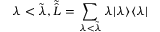Convert formula to latex. <formula><loc_0><loc_0><loc_500><loc_500>\lambda < \tilde { \lambda } , \tilde { \hat { L } } = \sum _ { \lambda < \tilde { \lambda } } \lambda | \lambda \rangle \langle \lambda |</formula> 